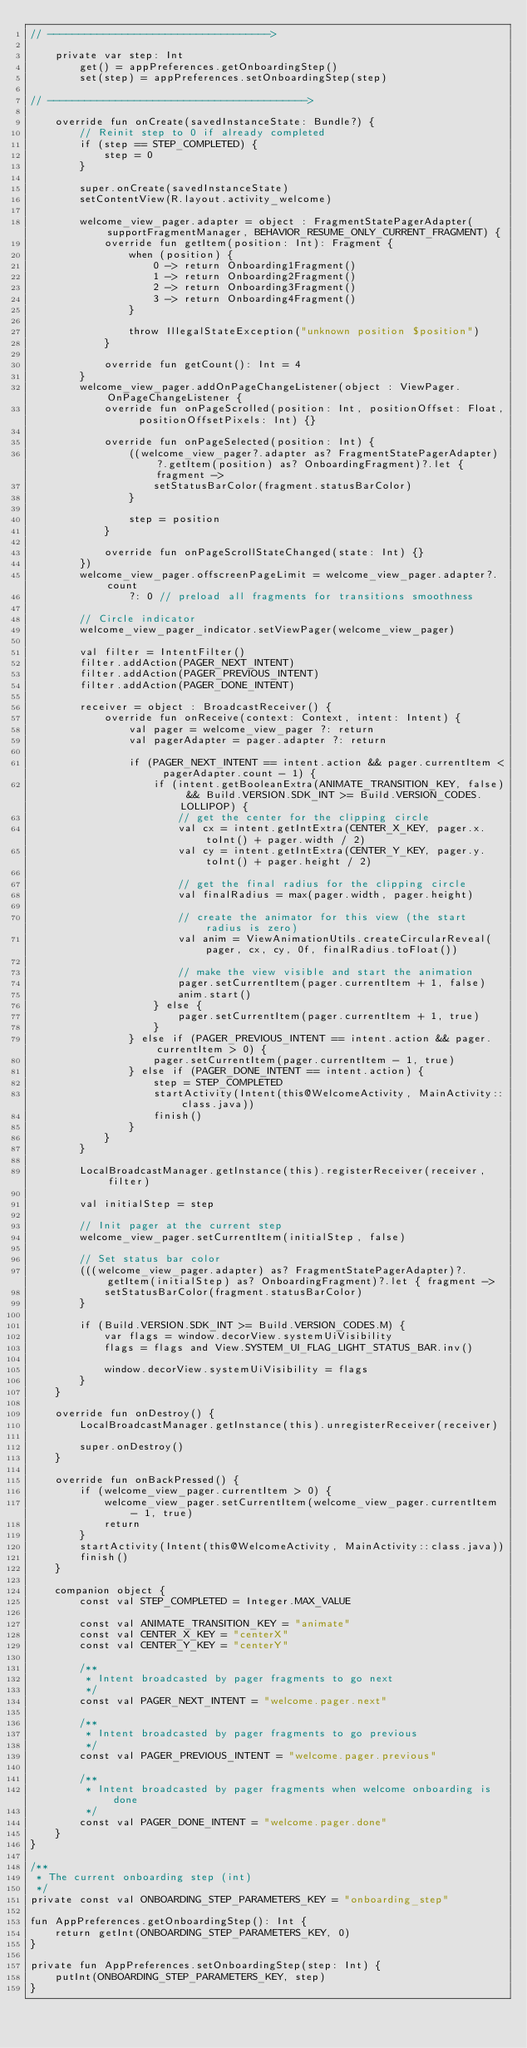<code> <loc_0><loc_0><loc_500><loc_500><_Kotlin_>// ------------------------------------>

    private var step: Int
        get() = appPreferences.getOnboardingStep()
        set(step) = appPreferences.setOnboardingStep(step)

// ------------------------------------------>

    override fun onCreate(savedInstanceState: Bundle?) {
        // Reinit step to 0 if already completed
        if (step == STEP_COMPLETED) {
            step = 0
        }

        super.onCreate(savedInstanceState)
        setContentView(R.layout.activity_welcome)

        welcome_view_pager.adapter = object : FragmentStatePagerAdapter(supportFragmentManager, BEHAVIOR_RESUME_ONLY_CURRENT_FRAGMENT) {
            override fun getItem(position: Int): Fragment {
                when (position) {
                    0 -> return Onboarding1Fragment()
                    1 -> return Onboarding2Fragment()
                    2 -> return Onboarding3Fragment()
                    3 -> return Onboarding4Fragment()
                }

                throw IllegalStateException("unknown position $position")
            }

            override fun getCount(): Int = 4
        }
        welcome_view_pager.addOnPageChangeListener(object : ViewPager.OnPageChangeListener {
            override fun onPageScrolled(position: Int, positionOffset: Float, positionOffsetPixels: Int) {}

            override fun onPageSelected(position: Int) {
                ((welcome_view_pager?.adapter as? FragmentStatePagerAdapter)?.getItem(position) as? OnboardingFragment)?.let { fragment ->
                    setStatusBarColor(fragment.statusBarColor)
                }

                step = position
            }

            override fun onPageScrollStateChanged(state: Int) {}
        })
        welcome_view_pager.offscreenPageLimit = welcome_view_pager.adapter?.count
                ?: 0 // preload all fragments for transitions smoothness

        // Circle indicator
        welcome_view_pager_indicator.setViewPager(welcome_view_pager)

        val filter = IntentFilter()
        filter.addAction(PAGER_NEXT_INTENT)
        filter.addAction(PAGER_PREVIOUS_INTENT)
        filter.addAction(PAGER_DONE_INTENT)

        receiver = object : BroadcastReceiver() {
            override fun onReceive(context: Context, intent: Intent) {
                val pager = welcome_view_pager ?: return
                val pagerAdapter = pager.adapter ?: return

                if (PAGER_NEXT_INTENT == intent.action && pager.currentItem < pagerAdapter.count - 1) {
                    if (intent.getBooleanExtra(ANIMATE_TRANSITION_KEY, false) && Build.VERSION.SDK_INT >= Build.VERSION_CODES.LOLLIPOP) {
                        // get the center for the clipping circle
                        val cx = intent.getIntExtra(CENTER_X_KEY, pager.x.toInt() + pager.width / 2)
                        val cy = intent.getIntExtra(CENTER_Y_KEY, pager.y.toInt() + pager.height / 2)

                        // get the final radius for the clipping circle
                        val finalRadius = max(pager.width, pager.height)

                        // create the animator for this view (the start radius is zero)
                        val anim = ViewAnimationUtils.createCircularReveal(pager, cx, cy, 0f, finalRadius.toFloat())

                        // make the view visible and start the animation
                        pager.setCurrentItem(pager.currentItem + 1, false)
                        anim.start()
                    } else {
                        pager.setCurrentItem(pager.currentItem + 1, true)
                    }
                } else if (PAGER_PREVIOUS_INTENT == intent.action && pager.currentItem > 0) {
                    pager.setCurrentItem(pager.currentItem - 1, true)
                } else if (PAGER_DONE_INTENT == intent.action) {
                    step = STEP_COMPLETED
                    startActivity(Intent(this@WelcomeActivity, MainActivity::class.java))
                    finish()
                }
            }
        }

        LocalBroadcastManager.getInstance(this).registerReceiver(receiver, filter)

        val initialStep = step

        // Init pager at the current step
        welcome_view_pager.setCurrentItem(initialStep, false)

        // Set status bar color
        (((welcome_view_pager.adapter) as? FragmentStatePagerAdapter)?.getItem(initialStep) as? OnboardingFragment)?.let { fragment ->
            setStatusBarColor(fragment.statusBarColor)
        }

        if (Build.VERSION.SDK_INT >= Build.VERSION_CODES.M) {
            var flags = window.decorView.systemUiVisibility
            flags = flags and View.SYSTEM_UI_FLAG_LIGHT_STATUS_BAR.inv()

            window.decorView.systemUiVisibility = flags
        }
    }

    override fun onDestroy() {
        LocalBroadcastManager.getInstance(this).unregisterReceiver(receiver)

        super.onDestroy()
    }

    override fun onBackPressed() {
        if (welcome_view_pager.currentItem > 0) {
            welcome_view_pager.setCurrentItem(welcome_view_pager.currentItem - 1, true)
            return
        }
        startActivity(Intent(this@WelcomeActivity, MainActivity::class.java))
        finish()
    }

    companion object {
        const val STEP_COMPLETED = Integer.MAX_VALUE

        const val ANIMATE_TRANSITION_KEY = "animate"
        const val CENTER_X_KEY = "centerX"
        const val CENTER_Y_KEY = "centerY"

        /**
         * Intent broadcasted by pager fragments to go next
         */
        const val PAGER_NEXT_INTENT = "welcome.pager.next"

        /**
         * Intent broadcasted by pager fragments to go previous
         */
        const val PAGER_PREVIOUS_INTENT = "welcome.pager.previous"

        /**
         * Intent broadcasted by pager fragments when welcome onboarding is done
         */
        const val PAGER_DONE_INTENT = "welcome.pager.done"
    }
}

/**
 * The current onboarding step (int)
 */
private const val ONBOARDING_STEP_PARAMETERS_KEY = "onboarding_step"

fun AppPreferences.getOnboardingStep(): Int {
    return getInt(ONBOARDING_STEP_PARAMETERS_KEY, 0)
}

private fun AppPreferences.setOnboardingStep(step: Int) {
    putInt(ONBOARDING_STEP_PARAMETERS_KEY, step)
}
</code> 